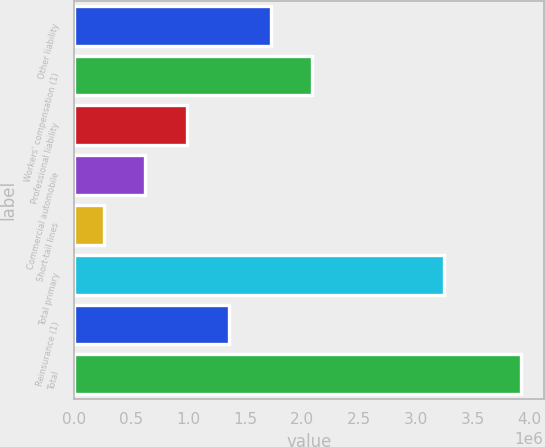Convert chart. <chart><loc_0><loc_0><loc_500><loc_500><bar_chart><fcel>Other liability<fcel>Workers' compensation (1)<fcel>Professional liability<fcel>Commercial automobile<fcel>Short-tail lines<fcel>Total primary<fcel>Reinsurance (1)<fcel>Total<nl><fcel>1.72542e+06<fcel>2.09216e+06<fcel>991940<fcel>625200<fcel>258459<fcel>3.24676e+06<fcel>1.35868e+06<fcel>3.92586e+06<nl></chart> 